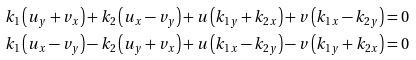Convert formula to latex. <formula><loc_0><loc_0><loc_500><loc_500>& { { k } _ { 1 } } \left ( { { u } _ { y } } + { { v } _ { x } } \right ) + { { k } _ { 2 } } \left ( { { u } _ { x } } - { { v } _ { y } } \right ) + u \left ( { { k } _ { 1 y } } + { { k } _ { 2 x } } \right ) + v \left ( { { k } _ { 1 x } } - { { k } _ { 2 y } } \right ) = 0 \\ & { { k } _ { 1 } } \left ( { { u } _ { x } } - { { v } _ { y } } \right ) - { { k } _ { 2 } } \left ( { { u } _ { y } } + { { v } _ { x } } \right ) + u \left ( { { k } _ { 1 x } } - { { k } _ { 2 y } } \right ) - v \left ( { { k } _ { 1 y } } + { { k } _ { 2 x } } \right ) = 0</formula> 